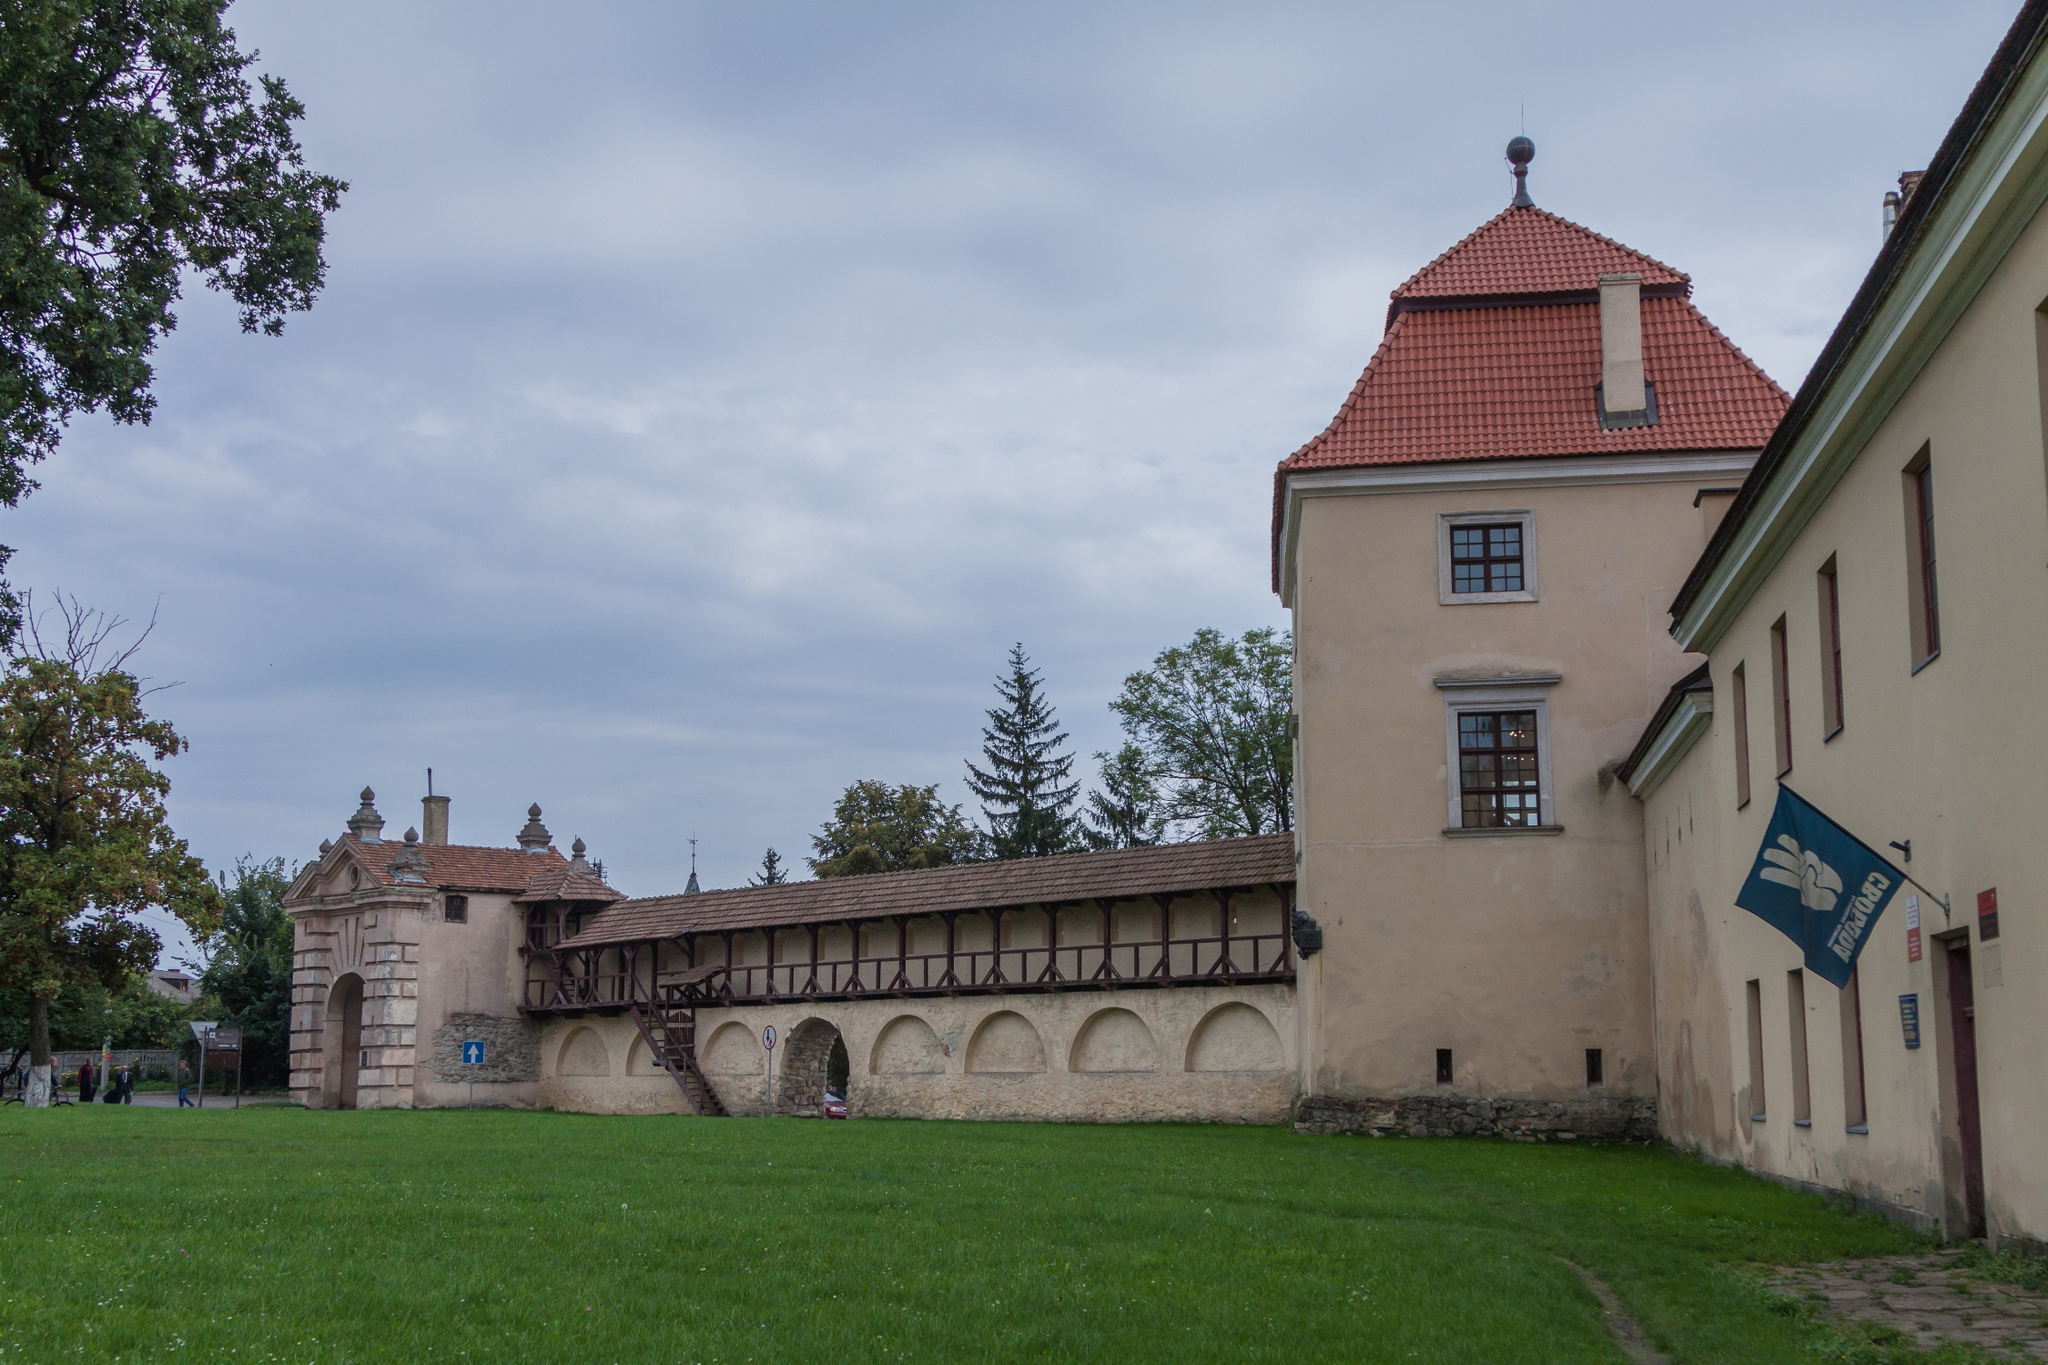Can you describe the historical significance this building might hold? This building may have significant historical value given its architectural style and setting. Such buildings are often remnants of previous centuries, serving as testimonies to architectural designs and cultural heritage from days gone by. This structure, with its fortified walls and distinct red tile roof, could have been a medieval manor, a military fort, or a grand estate owned by a noble family. The preserved walkway suggests it might have been a site of substantial activity, possibly used for administrative purposes, significant cultural events, or as a community hub. The peaceful environment today contrasts with its likely vibrant past, where it might have been a bustling center of medieval administration or defense. Its preservation suggests that it plays a crucial role in educating current generations about the historical landscape and societal developments of its time. What kind of events might have taken place here historically? Historically, this building could have been a venue for a variety of significant events. If it served as a noble estate, it might have hosted grand feasts, diplomatic meetings, and social gatherings of the elite. As a military fort, it could have been the site of planning and coordination during wartime, training drills, and possibly even skirmishes or defenses against invaders. If it functioned as a community center, it might have housed markets, festivals, public announcements, and civic activities. Ceremonial events such as coronations, legal proceedings, and treaties might also have taken place here. The thorough preservation of the building indicates its importance in such historical activities, offering a glimpse into the rich and diverse heritage of its time. 